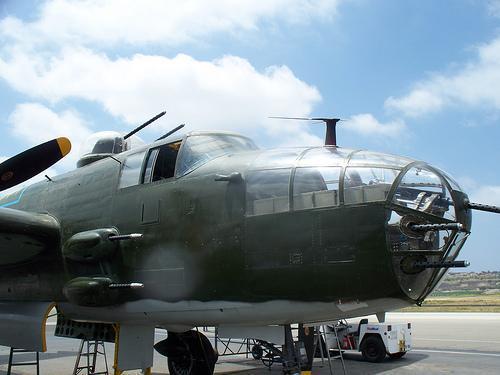How many planes are in the picture?
Give a very brief answer. 1. 